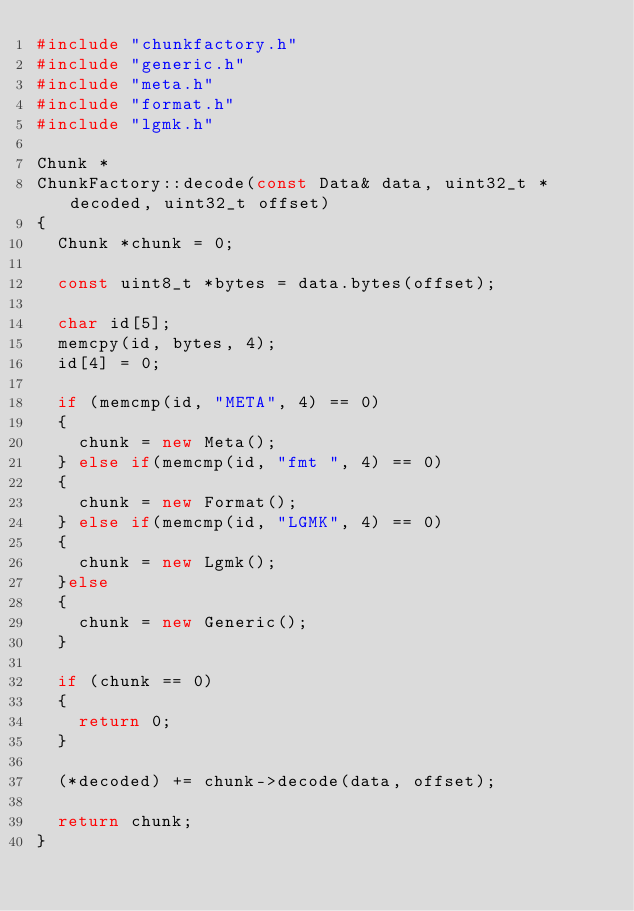<code> <loc_0><loc_0><loc_500><loc_500><_C++_>#include "chunkfactory.h"
#include "generic.h"
#include "meta.h"
#include "format.h"
#include "lgmk.h"

Chunk * 
ChunkFactory::decode(const Data& data, uint32_t *decoded, uint32_t offset)
{
	Chunk *chunk = 0;

	const uint8_t *bytes = data.bytes(offset);
	
	char id[5];
	memcpy(id, bytes, 4);
	id[4] = 0;
	
	if (memcmp(id, "META", 4) == 0)
	{
		chunk = new Meta();
	} else if(memcmp(id, "fmt ", 4) == 0)
	{
		chunk = new Format();
	} else if(memcmp(id, "LGMK", 4) == 0)
	{
		chunk = new Lgmk();
	}else
	{
		chunk = new Generic();
	}
	
	if (chunk == 0)
	{
		return 0;
	}

	(*decoded) += chunk->decode(data, offset);

	return chunk;
}

</code> 